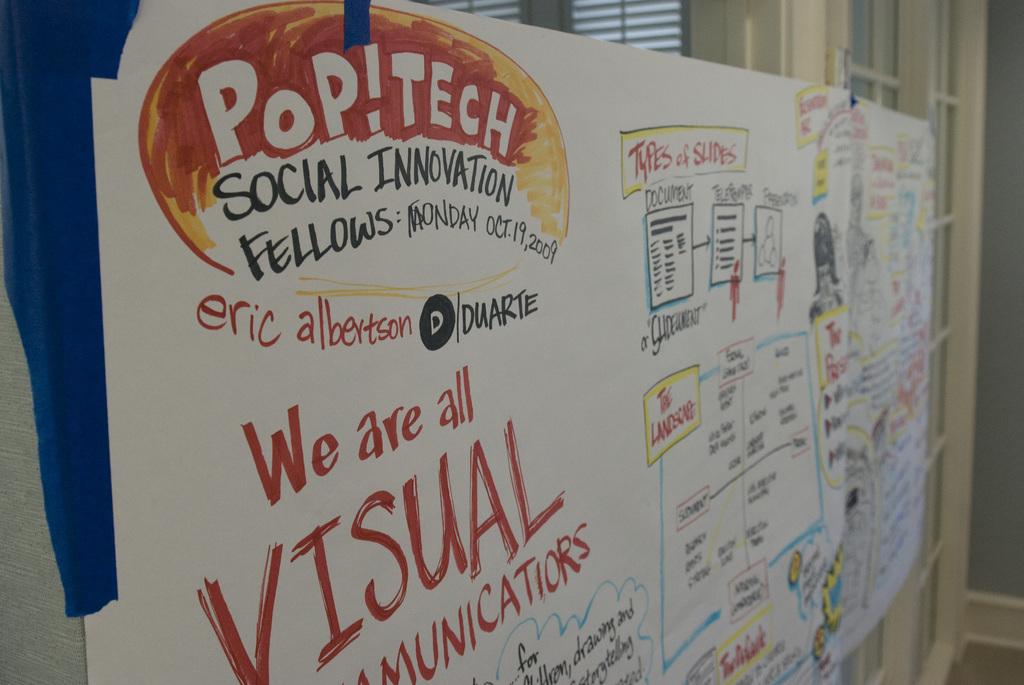Who made this board?
Offer a terse response. Eric albertson. What type of communicators are they?
Ensure brevity in your answer.  Visual. 